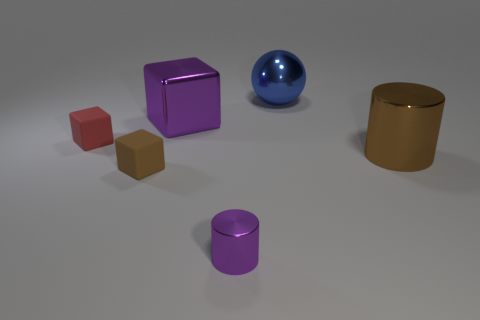Add 2 large red metallic cylinders. How many objects exist? 8 Subtract all cylinders. How many objects are left? 4 Add 4 tiny gray things. How many tiny gray things exist? 4 Subtract 1 purple cylinders. How many objects are left? 5 Subtract all red objects. Subtract all blue metal things. How many objects are left? 4 Add 2 small cubes. How many small cubes are left? 4 